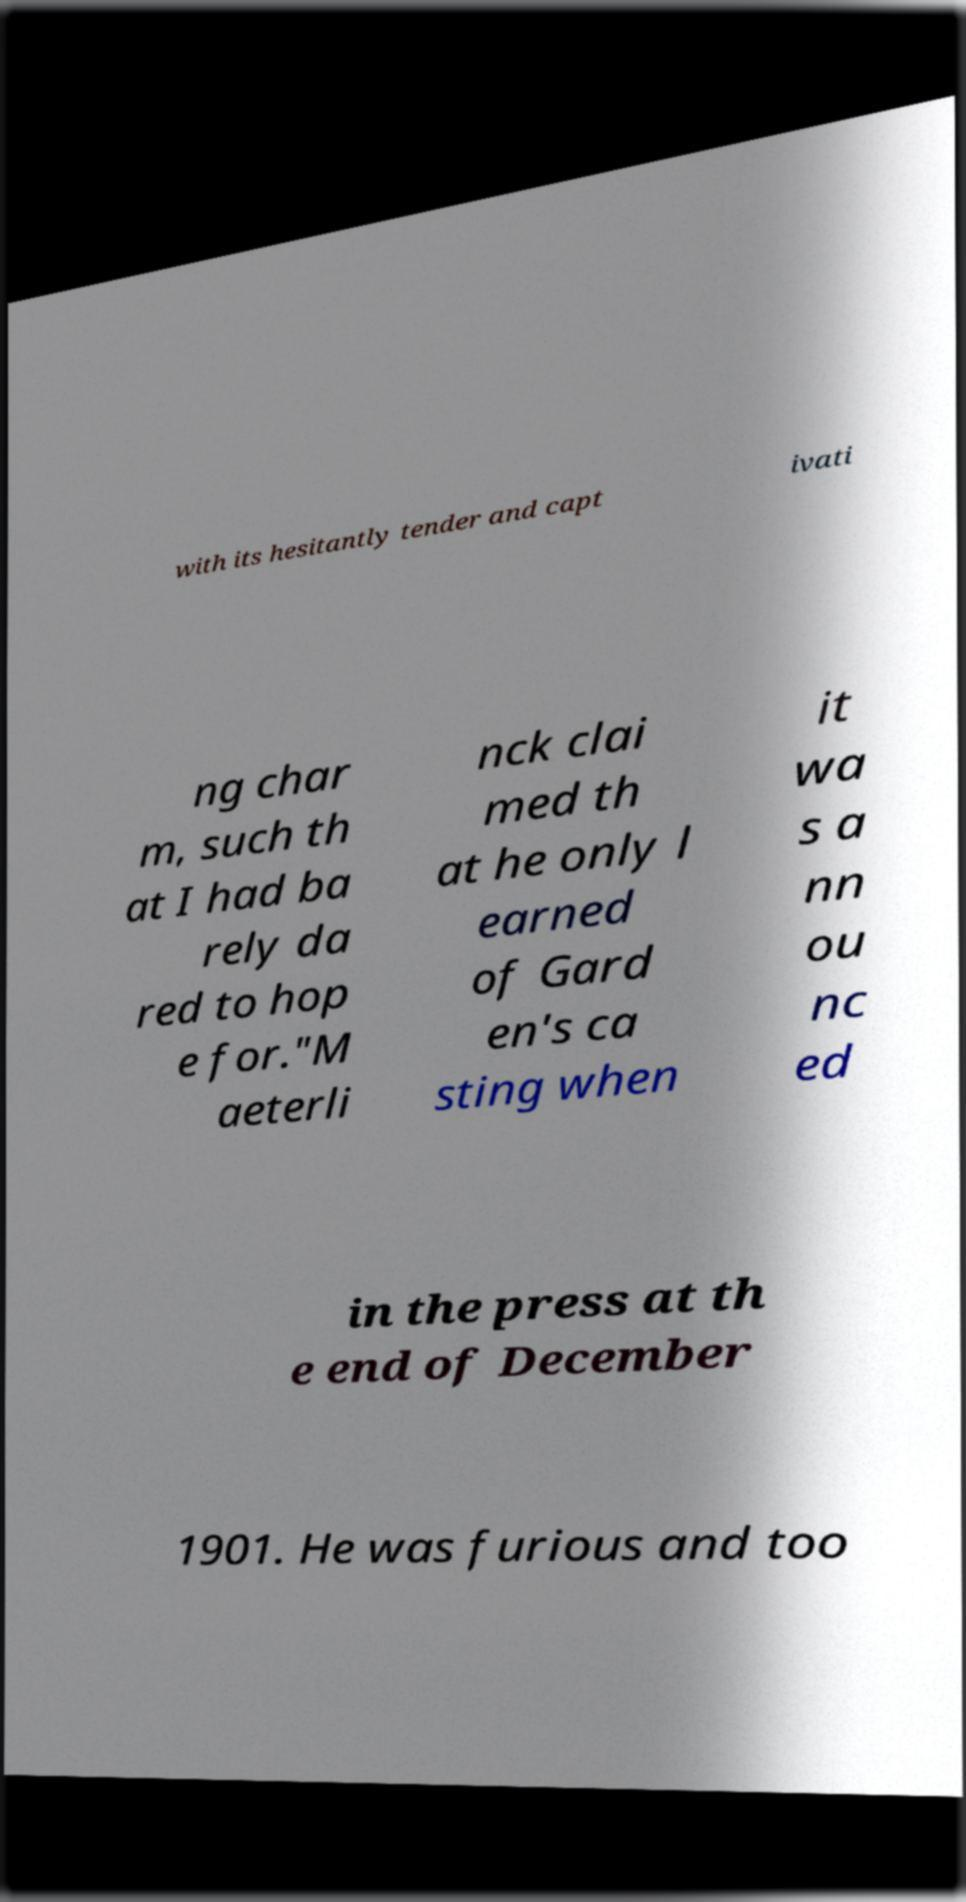Can you read and provide the text displayed in the image?This photo seems to have some interesting text. Can you extract and type it out for me? with its hesitantly tender and capt ivati ng char m, such th at I had ba rely da red to hop e for."M aeterli nck clai med th at he only l earned of Gard en's ca sting when it wa s a nn ou nc ed in the press at th e end of December 1901. He was furious and too 